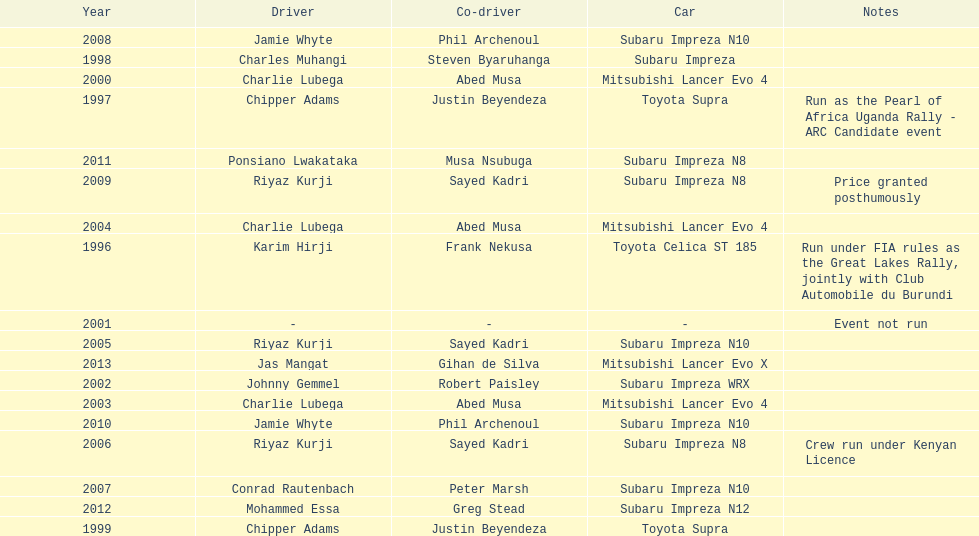Do chipper adams and justin beyendeza have more than 3 wins? No. 